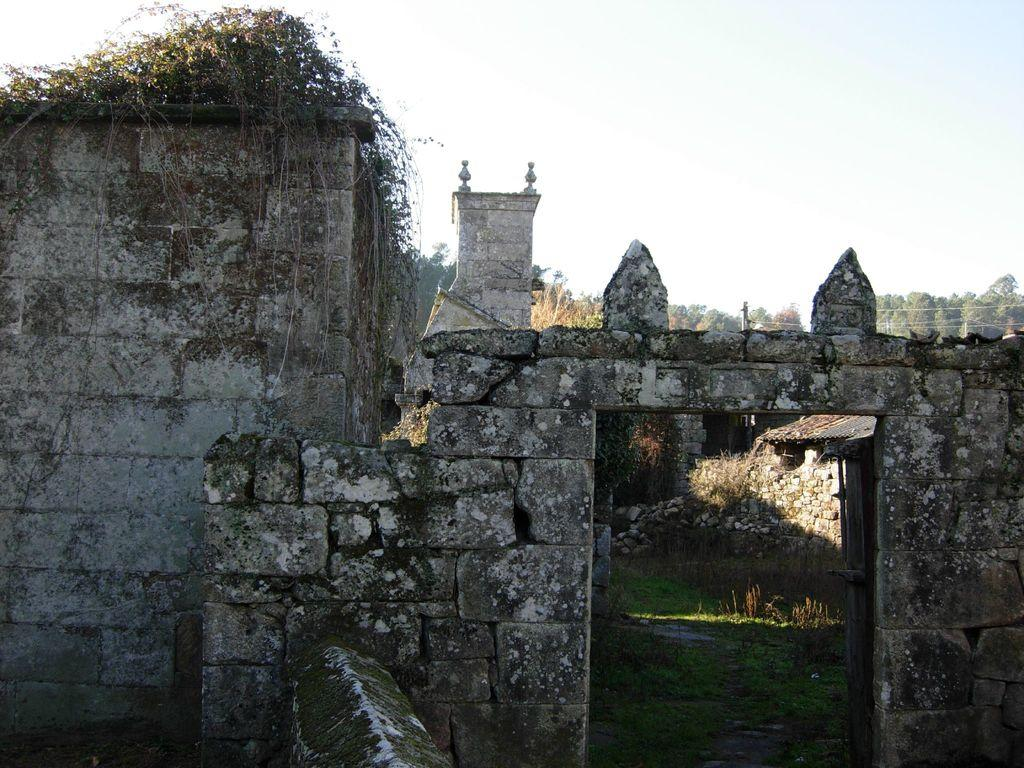What type of structure is depicted in the image? There is an ancient building in the image. What is inside the ancient building? The ancient building has grassland inside it. What can be seen in the background of the image? There are trees visible in the background of the image. What is visible above the ancient building? The sky is visible in the image. What is the name of the person who created the circle in the image? There is no circle present in the image, so it is not possible to determine the name of the person who created it. 